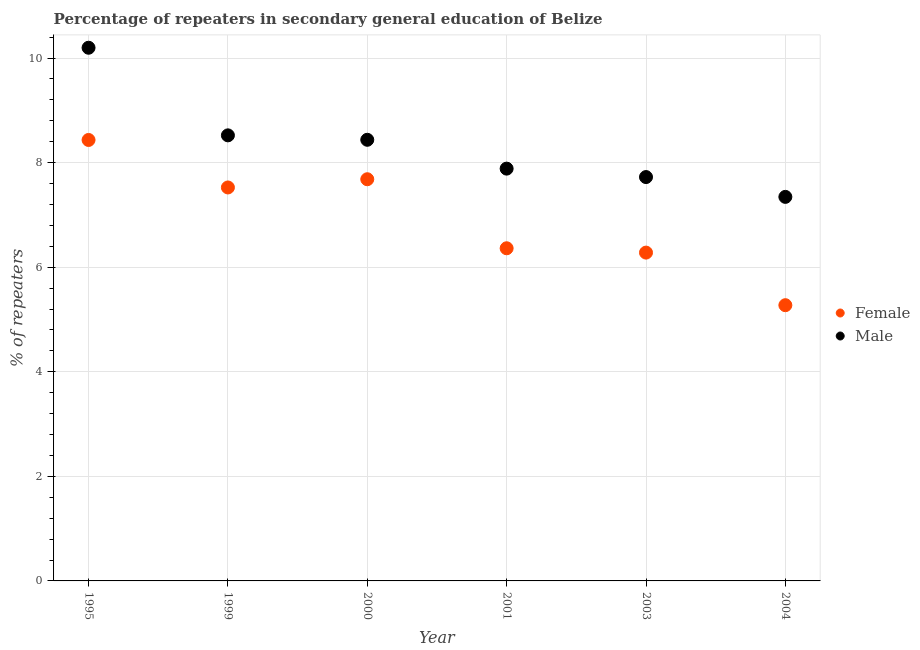Is the number of dotlines equal to the number of legend labels?
Make the answer very short. Yes. What is the percentage of male repeaters in 2004?
Provide a succinct answer. 7.34. Across all years, what is the maximum percentage of female repeaters?
Your response must be concise. 8.43. Across all years, what is the minimum percentage of female repeaters?
Provide a succinct answer. 5.27. What is the total percentage of male repeaters in the graph?
Ensure brevity in your answer.  50.11. What is the difference between the percentage of female repeaters in 2000 and that in 2004?
Ensure brevity in your answer.  2.41. What is the difference between the percentage of female repeaters in 1999 and the percentage of male repeaters in 1995?
Provide a succinct answer. -2.67. What is the average percentage of male repeaters per year?
Provide a short and direct response. 8.35. In the year 1999, what is the difference between the percentage of female repeaters and percentage of male repeaters?
Provide a short and direct response. -1. In how many years, is the percentage of male repeaters greater than 9.2 %?
Give a very brief answer. 1. What is the ratio of the percentage of male repeaters in 2001 to that in 2004?
Ensure brevity in your answer.  1.07. Is the difference between the percentage of male repeaters in 1995 and 2004 greater than the difference between the percentage of female repeaters in 1995 and 2004?
Offer a terse response. No. What is the difference between the highest and the second highest percentage of male repeaters?
Keep it short and to the point. 1.68. What is the difference between the highest and the lowest percentage of female repeaters?
Provide a succinct answer. 3.16. Does the percentage of male repeaters monotonically increase over the years?
Offer a terse response. No. Is the percentage of male repeaters strictly greater than the percentage of female repeaters over the years?
Your answer should be compact. Yes. How many dotlines are there?
Keep it short and to the point. 2. How many years are there in the graph?
Your answer should be compact. 6. Are the values on the major ticks of Y-axis written in scientific E-notation?
Your answer should be very brief. No. Where does the legend appear in the graph?
Your answer should be very brief. Center right. How many legend labels are there?
Offer a very short reply. 2. What is the title of the graph?
Offer a terse response. Percentage of repeaters in secondary general education of Belize. Does "Fraud firms" appear as one of the legend labels in the graph?
Ensure brevity in your answer.  No. What is the label or title of the Y-axis?
Make the answer very short. % of repeaters. What is the % of repeaters in Female in 1995?
Give a very brief answer. 8.43. What is the % of repeaters in Male in 1995?
Offer a terse response. 10.2. What is the % of repeaters of Female in 1999?
Provide a short and direct response. 7.52. What is the % of repeaters of Male in 1999?
Make the answer very short. 8.52. What is the % of repeaters in Female in 2000?
Ensure brevity in your answer.  7.68. What is the % of repeaters in Male in 2000?
Offer a very short reply. 8.44. What is the % of repeaters of Female in 2001?
Ensure brevity in your answer.  6.36. What is the % of repeaters of Male in 2001?
Provide a short and direct response. 7.88. What is the % of repeaters in Female in 2003?
Ensure brevity in your answer.  6.28. What is the % of repeaters in Male in 2003?
Offer a terse response. 7.72. What is the % of repeaters in Female in 2004?
Keep it short and to the point. 5.27. What is the % of repeaters of Male in 2004?
Your answer should be very brief. 7.34. Across all years, what is the maximum % of repeaters of Female?
Your answer should be compact. 8.43. Across all years, what is the maximum % of repeaters in Male?
Your answer should be compact. 10.2. Across all years, what is the minimum % of repeaters in Female?
Make the answer very short. 5.27. Across all years, what is the minimum % of repeaters of Male?
Your response must be concise. 7.34. What is the total % of repeaters of Female in the graph?
Offer a very short reply. 41.55. What is the total % of repeaters of Male in the graph?
Your answer should be compact. 50.11. What is the difference between the % of repeaters in Female in 1995 and that in 1999?
Your response must be concise. 0.91. What is the difference between the % of repeaters in Male in 1995 and that in 1999?
Give a very brief answer. 1.68. What is the difference between the % of repeaters in Female in 1995 and that in 2000?
Keep it short and to the point. 0.75. What is the difference between the % of repeaters in Male in 1995 and that in 2000?
Your answer should be very brief. 1.76. What is the difference between the % of repeaters in Female in 1995 and that in 2001?
Ensure brevity in your answer.  2.07. What is the difference between the % of repeaters of Male in 1995 and that in 2001?
Make the answer very short. 2.31. What is the difference between the % of repeaters in Female in 1995 and that in 2003?
Offer a terse response. 2.15. What is the difference between the % of repeaters in Male in 1995 and that in 2003?
Provide a short and direct response. 2.47. What is the difference between the % of repeaters in Female in 1995 and that in 2004?
Offer a terse response. 3.16. What is the difference between the % of repeaters of Male in 1995 and that in 2004?
Offer a terse response. 2.85. What is the difference between the % of repeaters of Female in 1999 and that in 2000?
Provide a succinct answer. -0.16. What is the difference between the % of repeaters in Male in 1999 and that in 2000?
Provide a succinct answer. 0.08. What is the difference between the % of repeaters in Female in 1999 and that in 2001?
Your answer should be very brief. 1.16. What is the difference between the % of repeaters in Male in 1999 and that in 2001?
Your answer should be compact. 0.64. What is the difference between the % of repeaters of Female in 1999 and that in 2003?
Offer a very short reply. 1.25. What is the difference between the % of repeaters of Male in 1999 and that in 2003?
Make the answer very short. 0.8. What is the difference between the % of repeaters in Female in 1999 and that in 2004?
Your response must be concise. 2.25. What is the difference between the % of repeaters in Male in 1999 and that in 2004?
Provide a short and direct response. 1.18. What is the difference between the % of repeaters in Female in 2000 and that in 2001?
Your response must be concise. 1.32. What is the difference between the % of repeaters in Male in 2000 and that in 2001?
Ensure brevity in your answer.  0.55. What is the difference between the % of repeaters of Female in 2000 and that in 2003?
Your answer should be compact. 1.4. What is the difference between the % of repeaters of Male in 2000 and that in 2003?
Give a very brief answer. 0.71. What is the difference between the % of repeaters in Female in 2000 and that in 2004?
Make the answer very short. 2.41. What is the difference between the % of repeaters of Male in 2000 and that in 2004?
Your answer should be very brief. 1.09. What is the difference between the % of repeaters of Female in 2001 and that in 2003?
Make the answer very short. 0.08. What is the difference between the % of repeaters of Male in 2001 and that in 2003?
Your answer should be compact. 0.16. What is the difference between the % of repeaters of Female in 2001 and that in 2004?
Provide a short and direct response. 1.09. What is the difference between the % of repeaters in Male in 2001 and that in 2004?
Offer a terse response. 0.54. What is the difference between the % of repeaters in Female in 2003 and that in 2004?
Make the answer very short. 1.01. What is the difference between the % of repeaters of Male in 2003 and that in 2004?
Your answer should be compact. 0.38. What is the difference between the % of repeaters of Female in 1995 and the % of repeaters of Male in 1999?
Give a very brief answer. -0.09. What is the difference between the % of repeaters in Female in 1995 and the % of repeaters in Male in 2000?
Make the answer very short. -0. What is the difference between the % of repeaters in Female in 1995 and the % of repeaters in Male in 2001?
Your answer should be very brief. 0.55. What is the difference between the % of repeaters in Female in 1995 and the % of repeaters in Male in 2003?
Make the answer very short. 0.71. What is the difference between the % of repeaters in Female in 1995 and the % of repeaters in Male in 2004?
Offer a terse response. 1.09. What is the difference between the % of repeaters of Female in 1999 and the % of repeaters of Male in 2000?
Provide a short and direct response. -0.91. What is the difference between the % of repeaters in Female in 1999 and the % of repeaters in Male in 2001?
Provide a succinct answer. -0.36. What is the difference between the % of repeaters in Female in 1999 and the % of repeaters in Male in 2003?
Provide a short and direct response. -0.2. What is the difference between the % of repeaters in Female in 1999 and the % of repeaters in Male in 2004?
Provide a succinct answer. 0.18. What is the difference between the % of repeaters in Female in 2000 and the % of repeaters in Male in 2001?
Your answer should be very brief. -0.2. What is the difference between the % of repeaters in Female in 2000 and the % of repeaters in Male in 2003?
Provide a succinct answer. -0.04. What is the difference between the % of repeaters in Female in 2000 and the % of repeaters in Male in 2004?
Keep it short and to the point. 0.34. What is the difference between the % of repeaters of Female in 2001 and the % of repeaters of Male in 2003?
Make the answer very short. -1.36. What is the difference between the % of repeaters of Female in 2001 and the % of repeaters of Male in 2004?
Keep it short and to the point. -0.98. What is the difference between the % of repeaters of Female in 2003 and the % of repeaters of Male in 2004?
Provide a short and direct response. -1.07. What is the average % of repeaters of Female per year?
Your response must be concise. 6.93. What is the average % of repeaters of Male per year?
Your response must be concise. 8.35. In the year 1995, what is the difference between the % of repeaters in Female and % of repeaters in Male?
Your response must be concise. -1.76. In the year 1999, what is the difference between the % of repeaters of Female and % of repeaters of Male?
Offer a terse response. -1. In the year 2000, what is the difference between the % of repeaters in Female and % of repeaters in Male?
Your answer should be compact. -0.75. In the year 2001, what is the difference between the % of repeaters of Female and % of repeaters of Male?
Your response must be concise. -1.52. In the year 2003, what is the difference between the % of repeaters in Female and % of repeaters in Male?
Give a very brief answer. -1.44. In the year 2004, what is the difference between the % of repeaters in Female and % of repeaters in Male?
Offer a very short reply. -2.07. What is the ratio of the % of repeaters in Female in 1995 to that in 1999?
Provide a short and direct response. 1.12. What is the ratio of the % of repeaters in Male in 1995 to that in 1999?
Offer a terse response. 1.2. What is the ratio of the % of repeaters of Female in 1995 to that in 2000?
Your response must be concise. 1.1. What is the ratio of the % of repeaters in Male in 1995 to that in 2000?
Your response must be concise. 1.21. What is the ratio of the % of repeaters of Female in 1995 to that in 2001?
Provide a succinct answer. 1.33. What is the ratio of the % of repeaters in Male in 1995 to that in 2001?
Offer a very short reply. 1.29. What is the ratio of the % of repeaters in Female in 1995 to that in 2003?
Ensure brevity in your answer.  1.34. What is the ratio of the % of repeaters in Male in 1995 to that in 2003?
Give a very brief answer. 1.32. What is the ratio of the % of repeaters of Female in 1995 to that in 2004?
Provide a short and direct response. 1.6. What is the ratio of the % of repeaters in Male in 1995 to that in 2004?
Offer a terse response. 1.39. What is the ratio of the % of repeaters of Female in 1999 to that in 2000?
Make the answer very short. 0.98. What is the ratio of the % of repeaters in Female in 1999 to that in 2001?
Make the answer very short. 1.18. What is the ratio of the % of repeaters in Male in 1999 to that in 2001?
Provide a short and direct response. 1.08. What is the ratio of the % of repeaters of Female in 1999 to that in 2003?
Offer a very short reply. 1.2. What is the ratio of the % of repeaters in Male in 1999 to that in 2003?
Ensure brevity in your answer.  1.1. What is the ratio of the % of repeaters in Female in 1999 to that in 2004?
Offer a terse response. 1.43. What is the ratio of the % of repeaters of Male in 1999 to that in 2004?
Offer a very short reply. 1.16. What is the ratio of the % of repeaters of Female in 2000 to that in 2001?
Your answer should be very brief. 1.21. What is the ratio of the % of repeaters in Male in 2000 to that in 2001?
Your answer should be very brief. 1.07. What is the ratio of the % of repeaters of Female in 2000 to that in 2003?
Offer a very short reply. 1.22. What is the ratio of the % of repeaters of Male in 2000 to that in 2003?
Keep it short and to the point. 1.09. What is the ratio of the % of repeaters in Female in 2000 to that in 2004?
Make the answer very short. 1.46. What is the ratio of the % of repeaters of Male in 2000 to that in 2004?
Your answer should be compact. 1.15. What is the ratio of the % of repeaters in Female in 2001 to that in 2003?
Offer a terse response. 1.01. What is the ratio of the % of repeaters of Male in 2001 to that in 2003?
Keep it short and to the point. 1.02. What is the ratio of the % of repeaters of Female in 2001 to that in 2004?
Keep it short and to the point. 1.21. What is the ratio of the % of repeaters of Male in 2001 to that in 2004?
Keep it short and to the point. 1.07. What is the ratio of the % of repeaters in Female in 2003 to that in 2004?
Keep it short and to the point. 1.19. What is the ratio of the % of repeaters of Male in 2003 to that in 2004?
Keep it short and to the point. 1.05. What is the difference between the highest and the second highest % of repeaters of Female?
Provide a short and direct response. 0.75. What is the difference between the highest and the second highest % of repeaters of Male?
Keep it short and to the point. 1.68. What is the difference between the highest and the lowest % of repeaters in Female?
Your response must be concise. 3.16. What is the difference between the highest and the lowest % of repeaters of Male?
Your response must be concise. 2.85. 